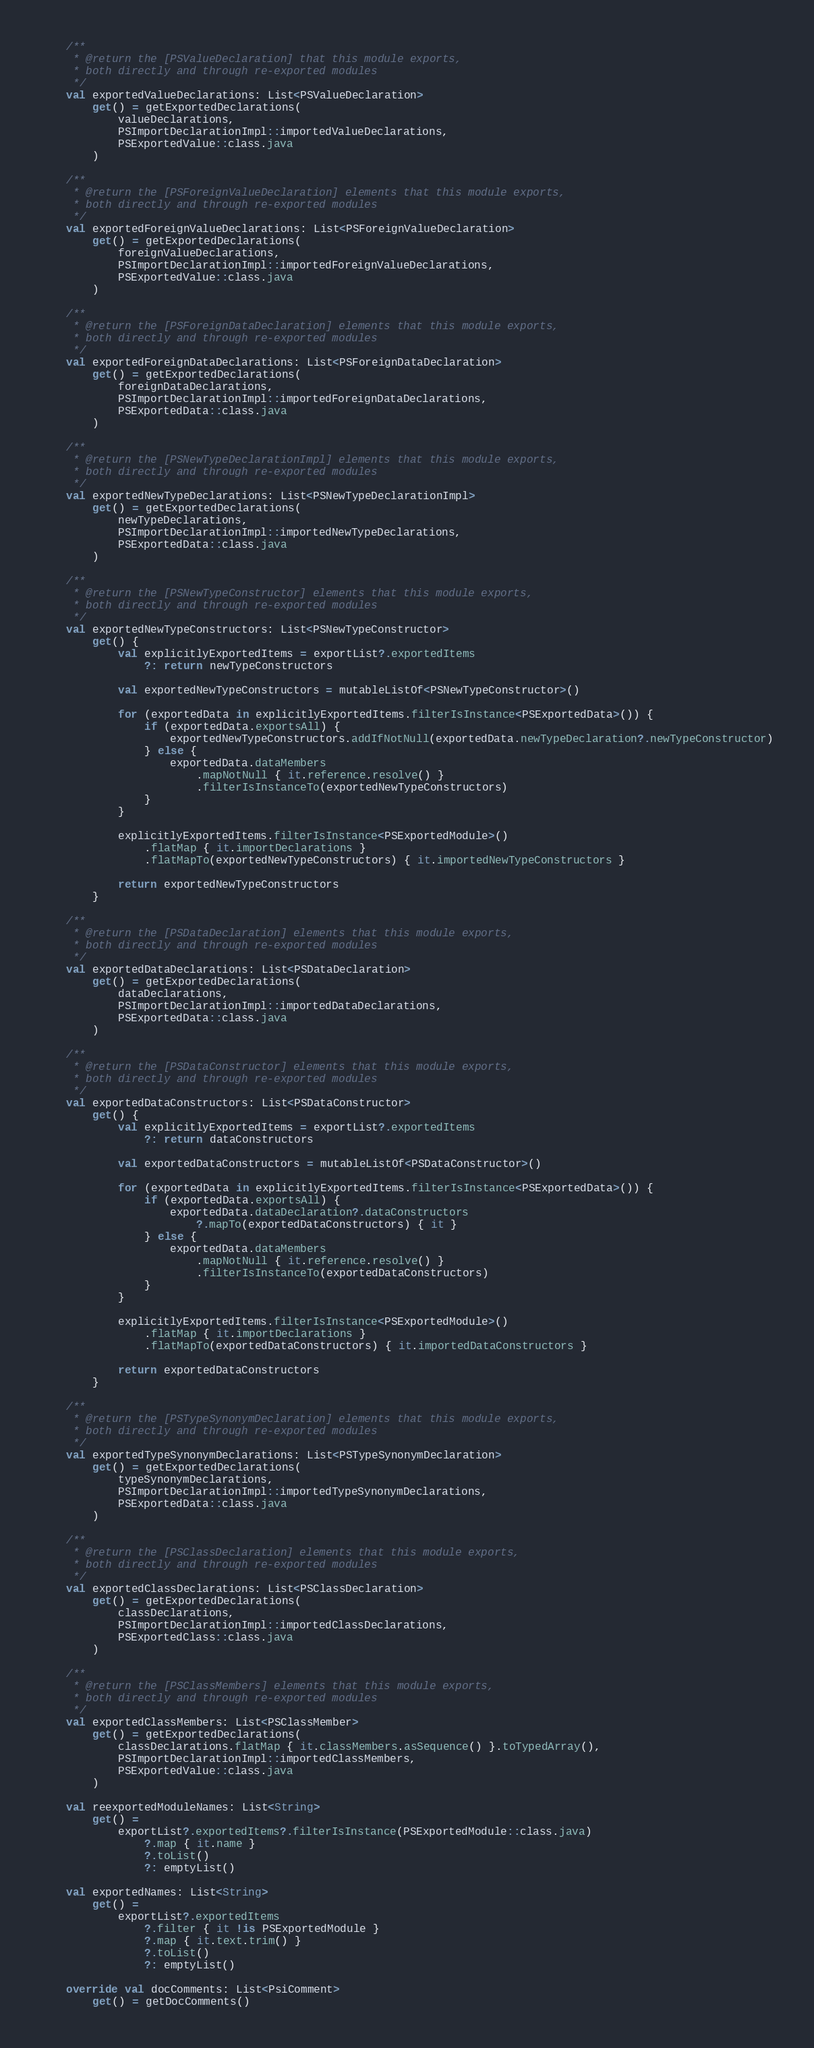<code> <loc_0><loc_0><loc_500><loc_500><_Kotlin_>
    /**
     * @return the [PSValueDeclaration] that this module exports,
     * both directly and through re-exported modules
     */
    val exportedValueDeclarations: List<PSValueDeclaration>
        get() = getExportedDeclarations(
            valueDeclarations,
            PSImportDeclarationImpl::importedValueDeclarations,
            PSExportedValue::class.java
        )

    /**
     * @return the [PSForeignValueDeclaration] elements that this module exports,
     * both directly and through re-exported modules
     */
    val exportedForeignValueDeclarations: List<PSForeignValueDeclaration>
        get() = getExportedDeclarations(
            foreignValueDeclarations,
            PSImportDeclarationImpl::importedForeignValueDeclarations,
            PSExportedValue::class.java
        )

    /**
     * @return the [PSForeignDataDeclaration] elements that this module exports,
     * both directly and through re-exported modules
     */
    val exportedForeignDataDeclarations: List<PSForeignDataDeclaration>
        get() = getExportedDeclarations(
            foreignDataDeclarations,
            PSImportDeclarationImpl::importedForeignDataDeclarations,
            PSExportedData::class.java
        )

    /**
     * @return the [PSNewTypeDeclarationImpl] elements that this module exports,
     * both directly and through re-exported modules
     */
    val exportedNewTypeDeclarations: List<PSNewTypeDeclarationImpl>
        get() = getExportedDeclarations(
            newTypeDeclarations,
            PSImportDeclarationImpl::importedNewTypeDeclarations,
            PSExportedData::class.java
        )

    /**
     * @return the [PSNewTypeConstructor] elements that this module exports,
     * both directly and through re-exported modules
     */
    val exportedNewTypeConstructors: List<PSNewTypeConstructor>
        get() {
            val explicitlyExportedItems = exportList?.exportedItems
                ?: return newTypeConstructors

            val exportedNewTypeConstructors = mutableListOf<PSNewTypeConstructor>()

            for (exportedData in explicitlyExportedItems.filterIsInstance<PSExportedData>()) {
                if (exportedData.exportsAll) {
                    exportedNewTypeConstructors.addIfNotNull(exportedData.newTypeDeclaration?.newTypeConstructor)
                } else {
                    exportedData.dataMembers
                        .mapNotNull { it.reference.resolve() }
                        .filterIsInstanceTo(exportedNewTypeConstructors)
                }
            }

            explicitlyExportedItems.filterIsInstance<PSExportedModule>()
                .flatMap { it.importDeclarations }
                .flatMapTo(exportedNewTypeConstructors) { it.importedNewTypeConstructors }

            return exportedNewTypeConstructors
        }

    /**
     * @return the [PSDataDeclaration] elements that this module exports,
     * both directly and through re-exported modules
     */
    val exportedDataDeclarations: List<PSDataDeclaration>
        get() = getExportedDeclarations(
            dataDeclarations,
            PSImportDeclarationImpl::importedDataDeclarations,
            PSExportedData::class.java
        )

    /**
     * @return the [PSDataConstructor] elements that this module exports,
     * both directly and through re-exported modules
     */
    val exportedDataConstructors: List<PSDataConstructor>
        get() {
            val explicitlyExportedItems = exportList?.exportedItems
                ?: return dataConstructors

            val exportedDataConstructors = mutableListOf<PSDataConstructor>()

            for (exportedData in explicitlyExportedItems.filterIsInstance<PSExportedData>()) {
                if (exportedData.exportsAll) {
                    exportedData.dataDeclaration?.dataConstructors
                        ?.mapTo(exportedDataConstructors) { it }
                } else {
                    exportedData.dataMembers
                        .mapNotNull { it.reference.resolve() }
                        .filterIsInstanceTo(exportedDataConstructors)
                }
            }

            explicitlyExportedItems.filterIsInstance<PSExportedModule>()
                .flatMap { it.importDeclarations }
                .flatMapTo(exportedDataConstructors) { it.importedDataConstructors }

            return exportedDataConstructors
        }

    /**
     * @return the [PSTypeSynonymDeclaration] elements that this module exports,
     * both directly and through re-exported modules
     */
    val exportedTypeSynonymDeclarations: List<PSTypeSynonymDeclaration>
        get() = getExportedDeclarations(
            typeSynonymDeclarations,
            PSImportDeclarationImpl::importedTypeSynonymDeclarations,
            PSExportedData::class.java
        )

    /**
     * @return the [PSClassDeclaration] elements that this module exports,
     * both directly and through re-exported modules
     */
    val exportedClassDeclarations: List<PSClassDeclaration>
        get() = getExportedDeclarations(
            classDeclarations,
            PSImportDeclarationImpl::importedClassDeclarations,
            PSExportedClass::class.java
        )

    /**
     * @return the [PSClassMembers] elements that this module exports,
     * both directly and through re-exported modules
     */
    val exportedClassMembers: List<PSClassMember>
        get() = getExportedDeclarations(
            classDeclarations.flatMap { it.classMembers.asSequence() }.toTypedArray(),
            PSImportDeclarationImpl::importedClassMembers,
            PSExportedValue::class.java
        )

    val reexportedModuleNames: List<String>
        get() =
            exportList?.exportedItems?.filterIsInstance(PSExportedModule::class.java)
                ?.map { it.name }
                ?.toList()
                ?: emptyList()

    val exportedNames: List<String>
        get() =
            exportList?.exportedItems
                ?.filter { it !is PSExportedModule }
                ?.map { it.text.trim() }
                ?.toList()
                ?: emptyList()

    override val docComments: List<PsiComment>
        get() = getDocComments()
</code> 